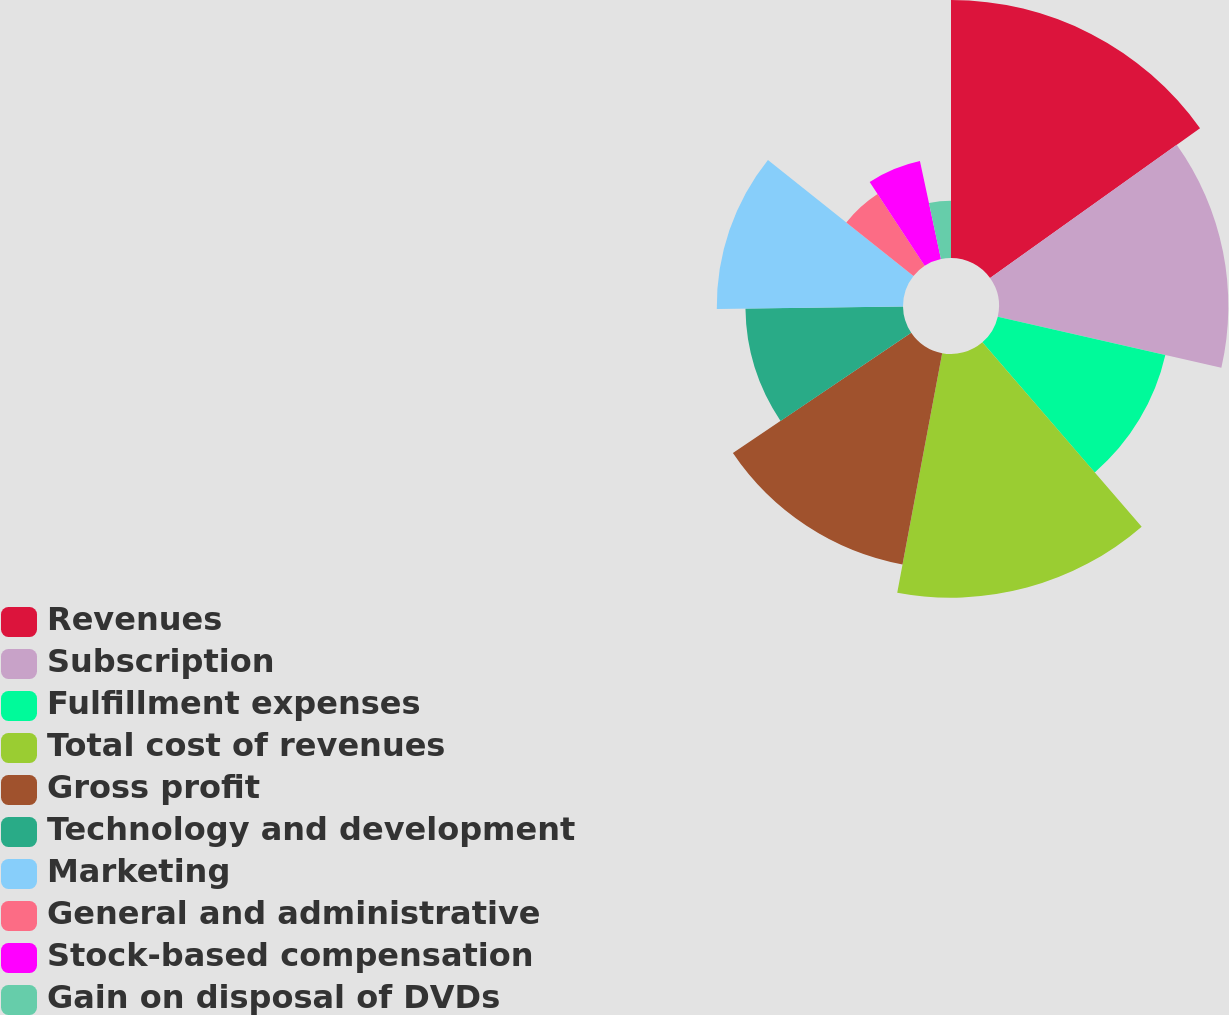Convert chart. <chart><loc_0><loc_0><loc_500><loc_500><pie_chart><fcel>Revenues<fcel>Subscription<fcel>Fulfillment expenses<fcel>Total cost of revenues<fcel>Gross profit<fcel>Technology and development<fcel>Marketing<fcel>General and administrative<fcel>Stock-based compensation<fcel>Gain on disposal of DVDs<nl><fcel>15.13%<fcel>13.45%<fcel>10.08%<fcel>14.29%<fcel>12.61%<fcel>9.24%<fcel>10.92%<fcel>5.04%<fcel>5.88%<fcel>3.36%<nl></chart> 